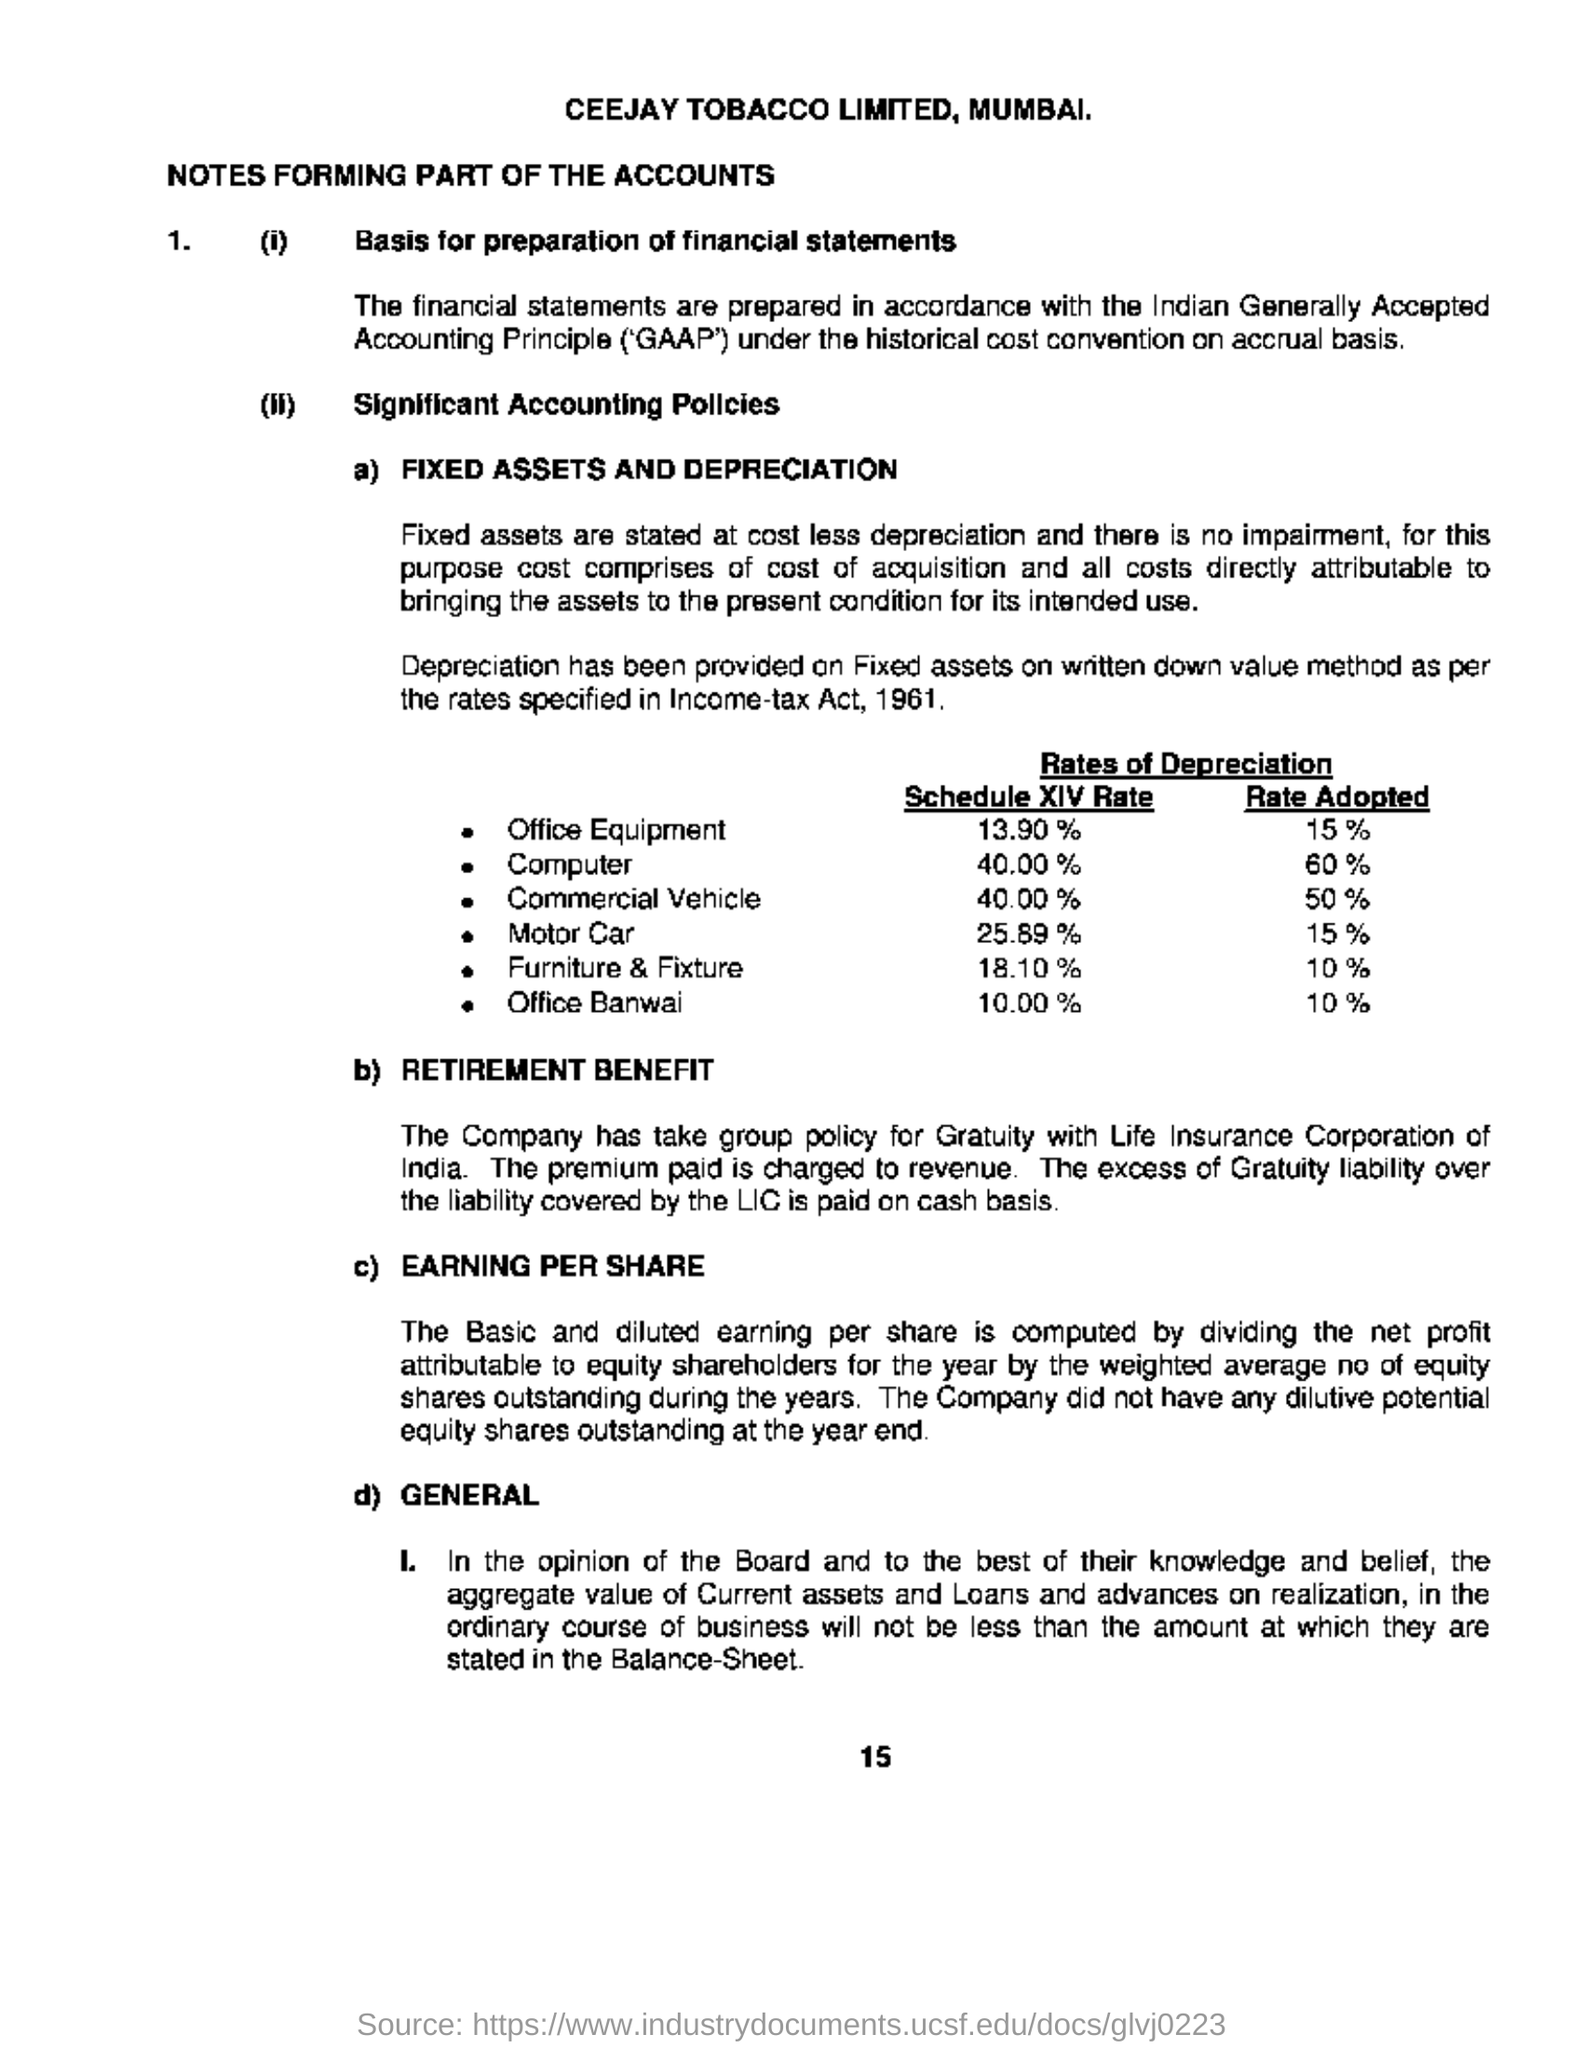What is the company name?
Provide a succinct answer. Ceejay tobacco limited. Where is ceejay tobacco limited located?
Keep it short and to the point. Mumbai. What is the income tax act year mentioned?
Keep it short and to the point. 1961. How much is the rate adopted for office equipment?
Your answer should be very brief. 15%. With which corporation does the company has take group policy for gratuity?
Make the answer very short. Life insurance corporation of india. 